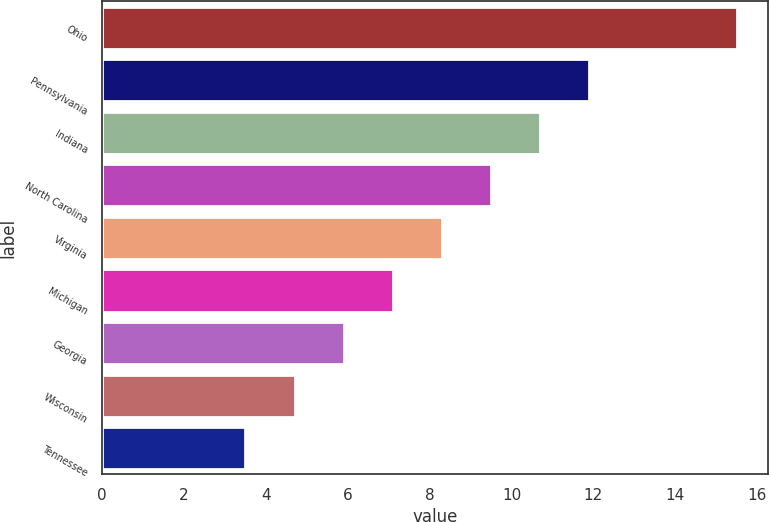Convert chart. <chart><loc_0><loc_0><loc_500><loc_500><bar_chart><fcel>Ohio<fcel>Pennsylvania<fcel>Indiana<fcel>North Carolina<fcel>Virginia<fcel>Michigan<fcel>Georgia<fcel>Wisconsin<fcel>Tennessee<nl><fcel>15.5<fcel>11.9<fcel>10.7<fcel>9.5<fcel>8.3<fcel>7.1<fcel>5.9<fcel>4.7<fcel>3.5<nl></chart> 